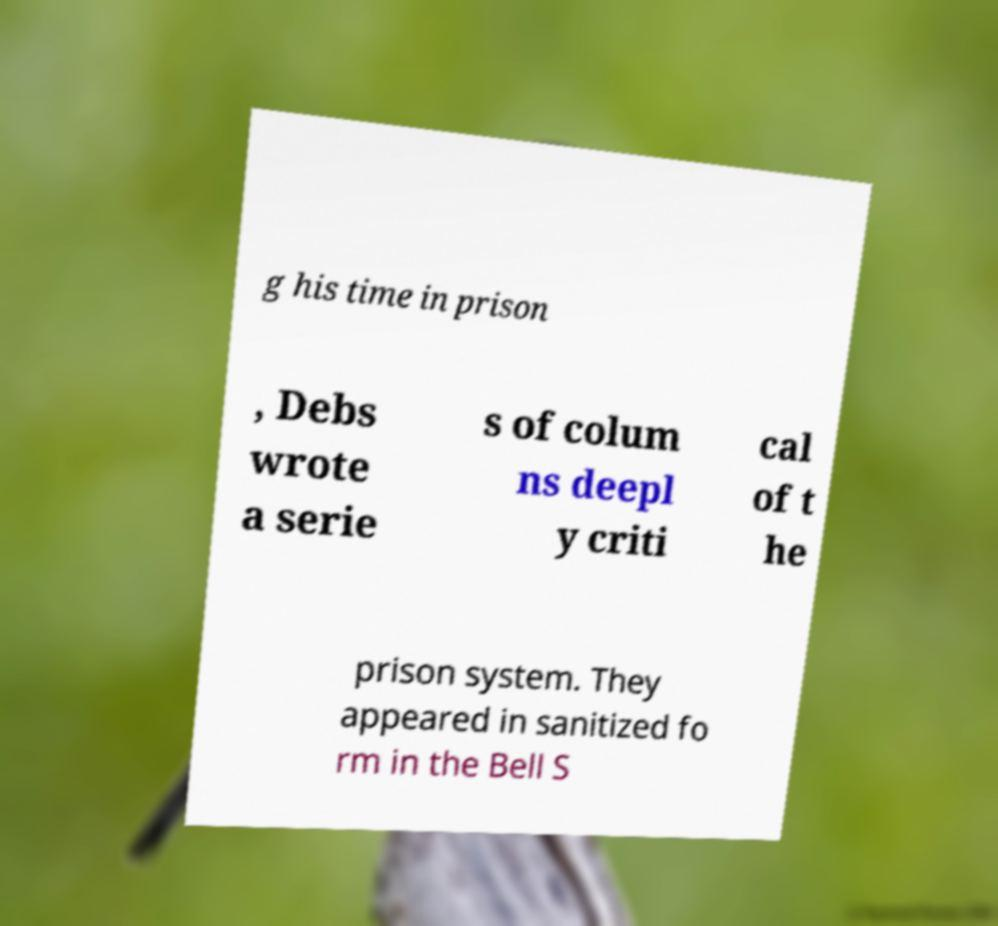There's text embedded in this image that I need extracted. Can you transcribe it verbatim? g his time in prison , Debs wrote a serie s of colum ns deepl y criti cal of t he prison system. They appeared in sanitized fo rm in the Bell S 